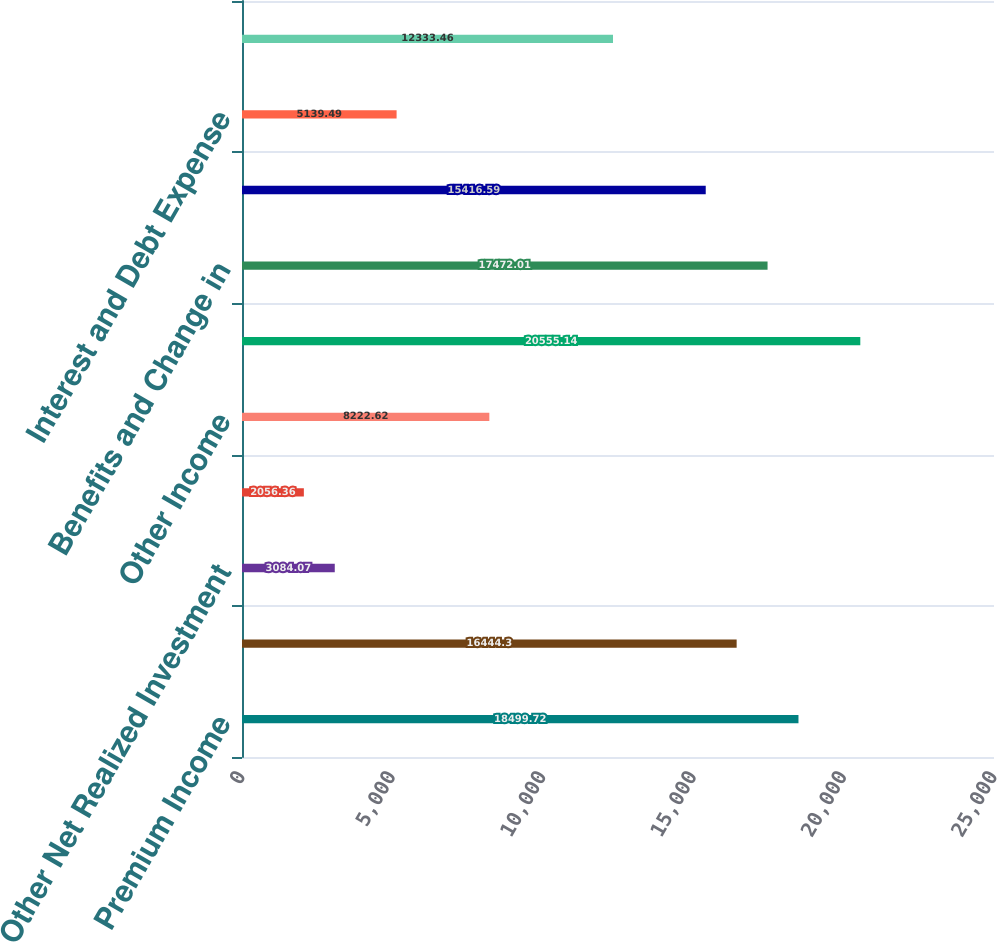Convert chart to OTSL. <chart><loc_0><loc_0><loc_500><loc_500><bar_chart><fcel>Premium Income<fcel>Net Investment Income<fcel>Other Net Realized Investment<fcel>Net Realized Investment Gain<fcel>Other Income<fcel>Total Revenue<fcel>Benefits and Change in<fcel>Commissions<fcel>Interest and Debt Expense<fcel>Deferral of Acquisition Costs<nl><fcel>18499.7<fcel>16444.3<fcel>3084.07<fcel>2056.36<fcel>8222.62<fcel>20555.1<fcel>17472<fcel>15416.6<fcel>5139.49<fcel>12333.5<nl></chart> 